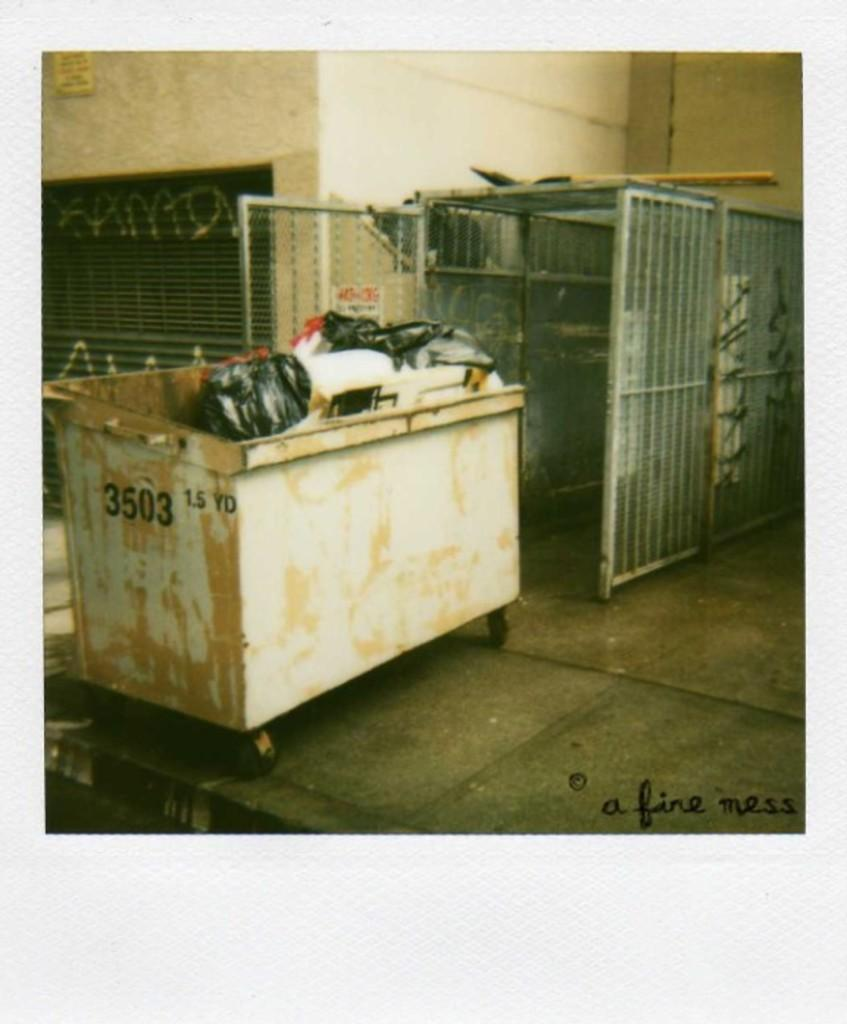<image>
Create a compact narrative representing the image presented. a dumpster with the numbers 3503 1.5 yd on the side of it 